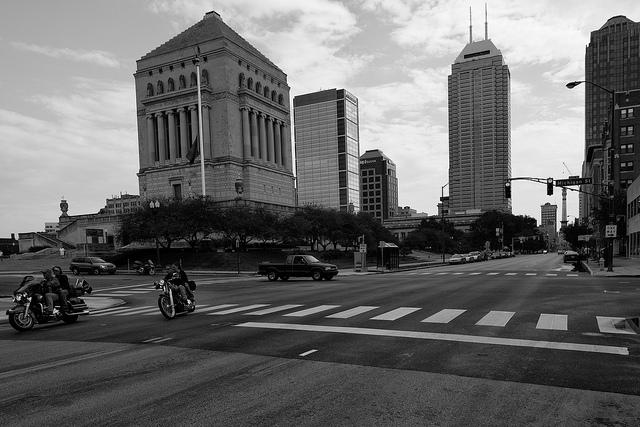Is this a colorful picture?
Be succinct. No. What are they riding?
Answer briefly. Motorcycles. What city is this in?
Concise answer only. New york. How many trucks are on the road?
Write a very short answer. 1. 